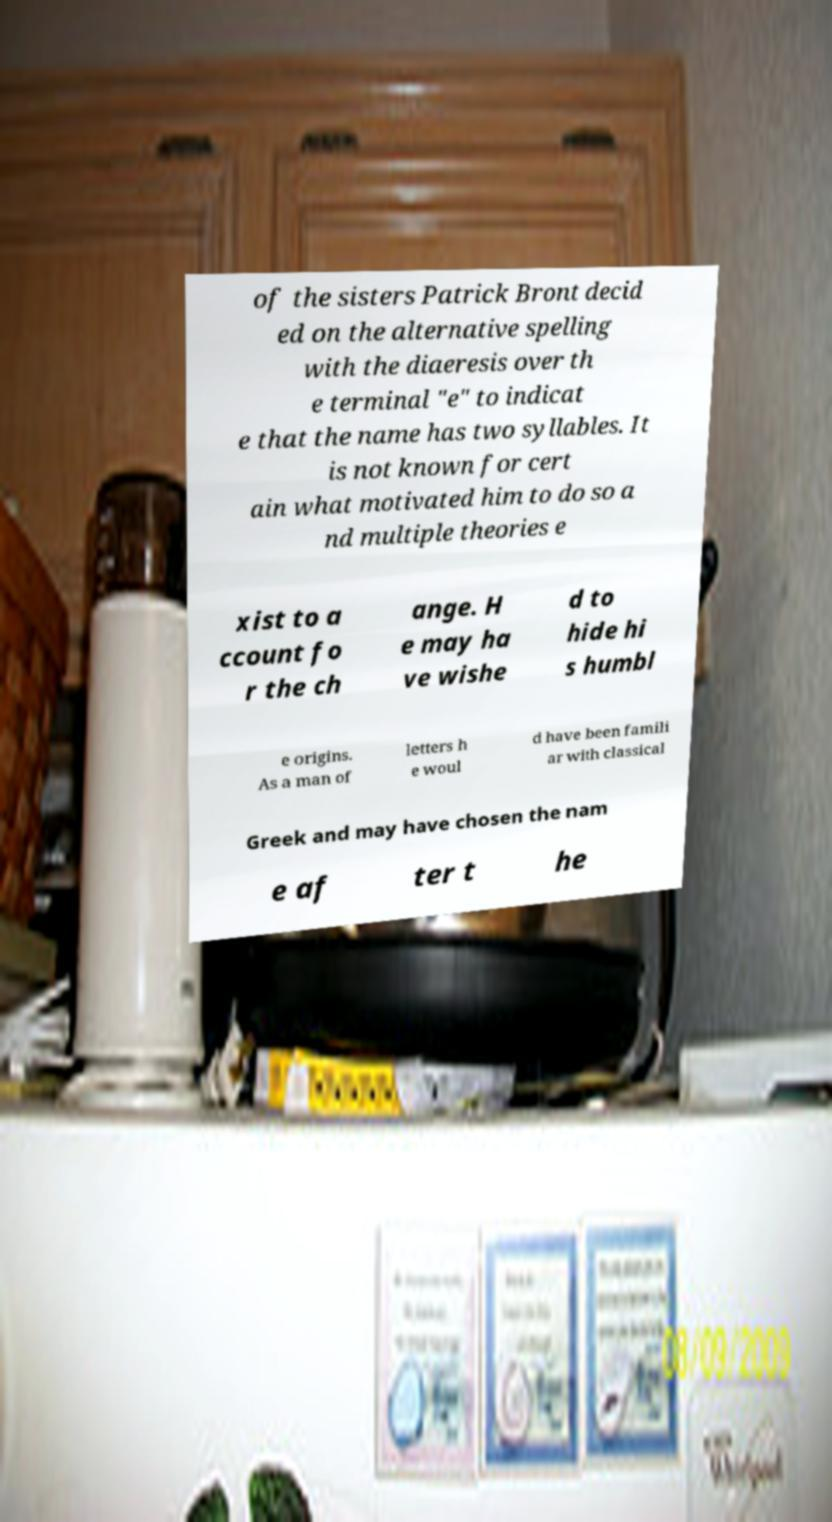Can you accurately transcribe the text from the provided image for me? of the sisters Patrick Bront decid ed on the alternative spelling with the diaeresis over th e terminal "e" to indicat e that the name has two syllables. It is not known for cert ain what motivated him to do so a nd multiple theories e xist to a ccount fo r the ch ange. H e may ha ve wishe d to hide hi s humbl e origins. As a man of letters h e woul d have been famili ar with classical Greek and may have chosen the nam e af ter t he 